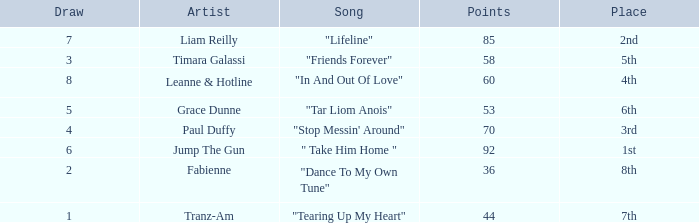What's the total number of points for grace dunne with a draw over 5? 0.0. 